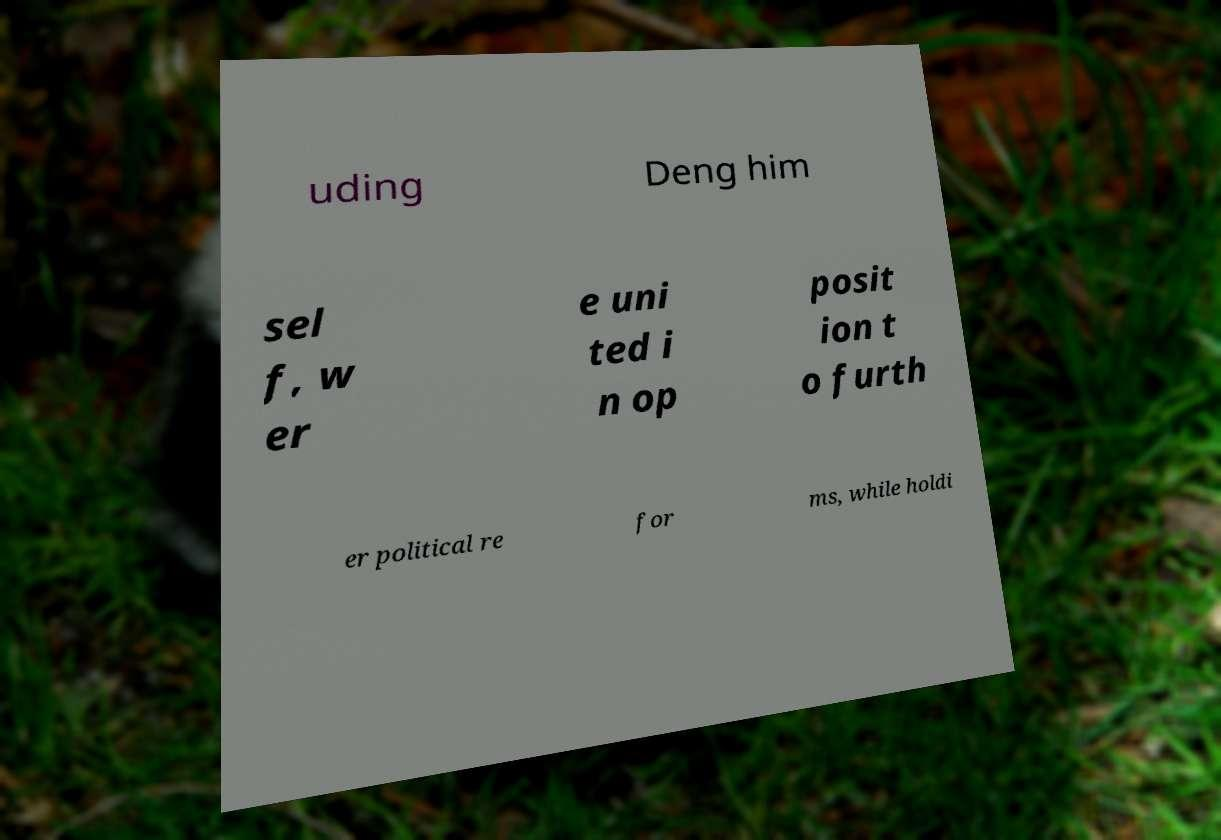There's text embedded in this image that I need extracted. Can you transcribe it verbatim? uding Deng him sel f, w er e uni ted i n op posit ion t o furth er political re for ms, while holdi 